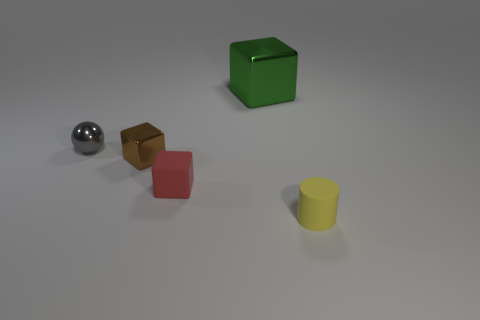There is a object that is in front of the green thing and to the right of the red thing; what size is it?
Offer a very short reply. Small. How many other things are the same size as the yellow thing?
Make the answer very short. 3. How many rubber objects are either red cubes or objects?
Your answer should be compact. 2. There is a small brown cube that is left of the small matte thing left of the small yellow cylinder; what is it made of?
Offer a very short reply. Metal. How many things are large yellow metallic blocks or small rubber things in front of the red rubber object?
Your answer should be compact. 1. The red cube that is the same material as the yellow object is what size?
Make the answer very short. Small. What number of red things are either large objects or small cylinders?
Your answer should be very brief. 0. Are there any other things that are the same material as the gray sphere?
Offer a very short reply. Yes. Do the rubber thing that is to the right of the small red thing and the object behind the gray metallic thing have the same shape?
Keep it short and to the point. No. What number of tiny shiny objects are there?
Provide a short and direct response. 2. 